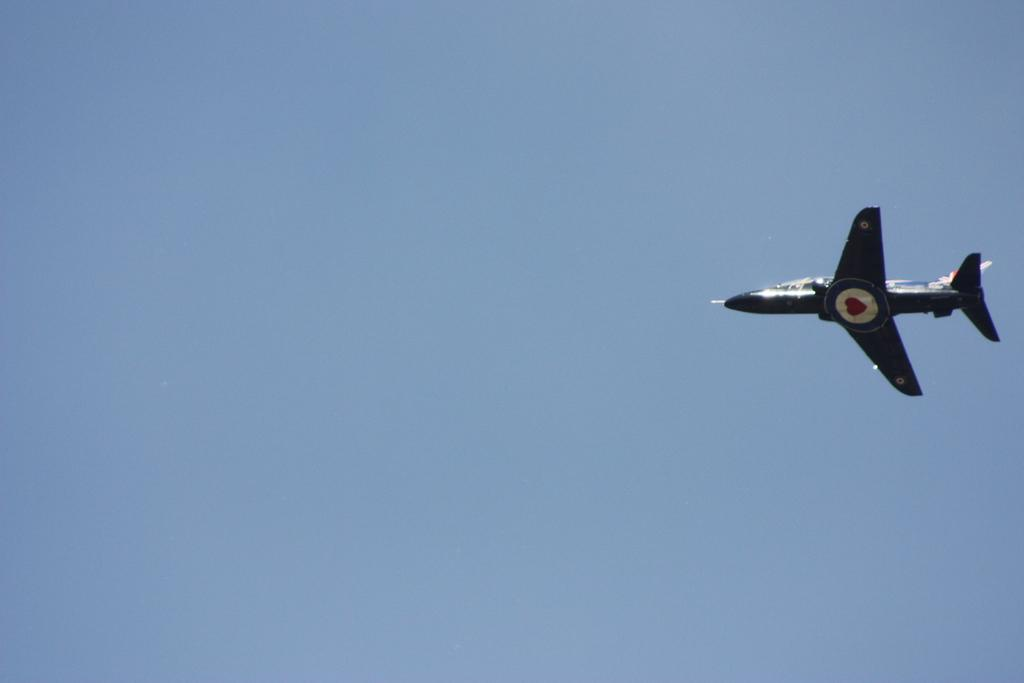What is the main subject of the image? The main subject of the image is an aeroplane. Where is the aeroplane located in the image? The aeroplane is in the sky. What thoughts are the brothers having while walking on the sidewalk in the image? There are no brothers or sidewalk present in the image; it features an aeroplane in the sky. 